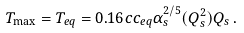Convert formula to latex. <formula><loc_0><loc_0><loc_500><loc_500>T _ { \max } = T _ { e q } = 0 . 1 6 c c _ { e q } \alpha _ { s } ^ { 2 / 5 } ( Q _ { s } ^ { 2 } ) Q _ { s } \, .</formula> 